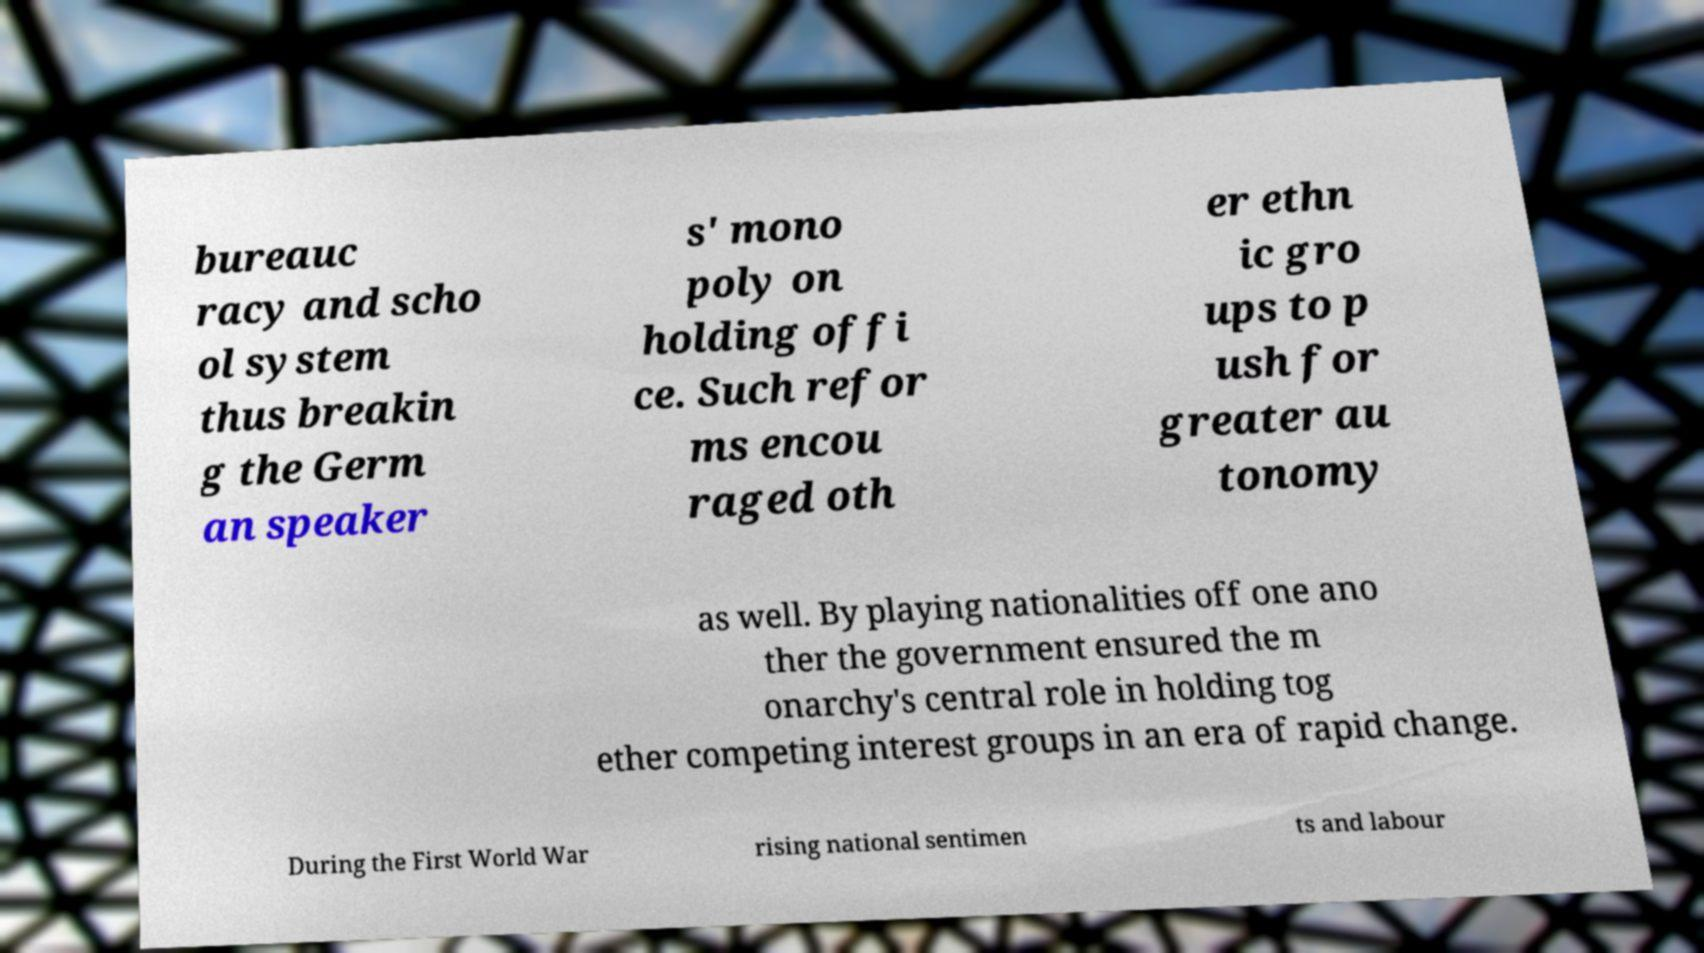Could you assist in decoding the text presented in this image and type it out clearly? bureauc racy and scho ol system thus breakin g the Germ an speaker s' mono poly on holding offi ce. Such refor ms encou raged oth er ethn ic gro ups to p ush for greater au tonomy as well. By playing nationalities off one ano ther the government ensured the m onarchy's central role in holding tog ether competing interest groups in an era of rapid change. During the First World War rising national sentimen ts and labour 